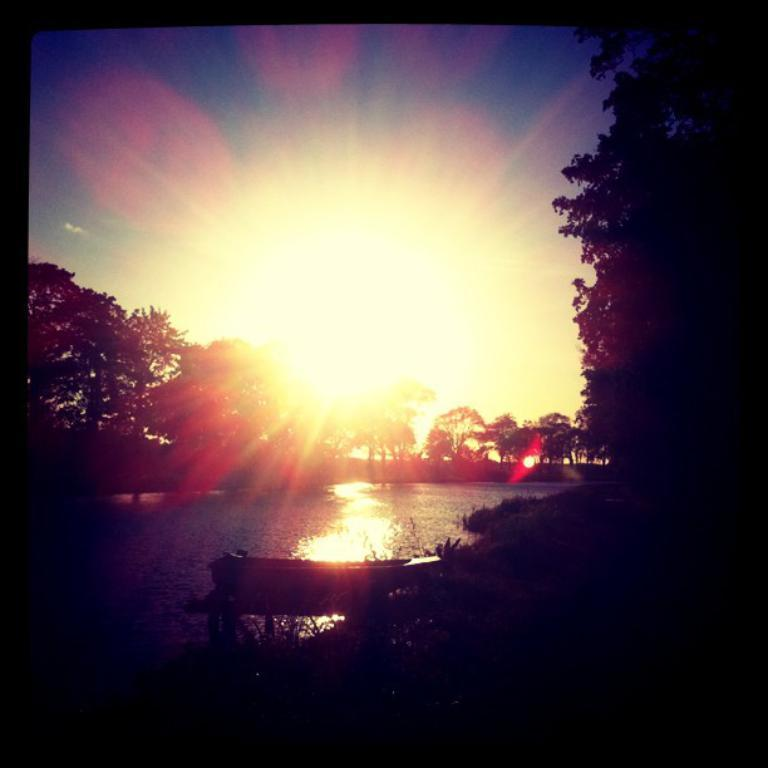What is located on the right side in the front of the image? There is a tree on the right side in the front of the image. What can be seen in the background of the image? There are trees visible in the background of the image. What is in the center of the image? There is water in the center of the image. What is the source of light in the image? Sun rays are visible in the image. What invention is being demonstrated in the image? There is no invention being demonstrated in the image; it features a tree, trees in the background, water, and sun rays. What phase of the moon is visible in the image? There is no moon visible in the image; it features sun rays as the source of light. 